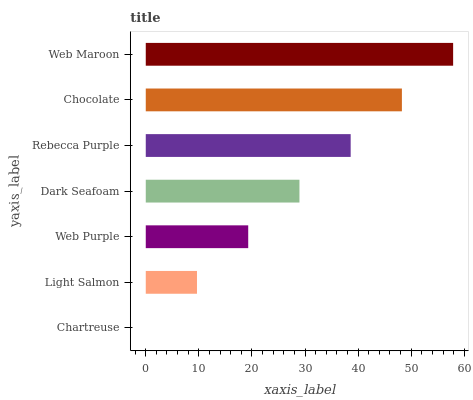Is Chartreuse the minimum?
Answer yes or no. Yes. Is Web Maroon the maximum?
Answer yes or no. Yes. Is Light Salmon the minimum?
Answer yes or no. No. Is Light Salmon the maximum?
Answer yes or no. No. Is Light Salmon greater than Chartreuse?
Answer yes or no. Yes. Is Chartreuse less than Light Salmon?
Answer yes or no. Yes. Is Chartreuse greater than Light Salmon?
Answer yes or no. No. Is Light Salmon less than Chartreuse?
Answer yes or no. No. Is Dark Seafoam the high median?
Answer yes or no. Yes. Is Dark Seafoam the low median?
Answer yes or no. Yes. Is Rebecca Purple the high median?
Answer yes or no. No. Is Light Salmon the low median?
Answer yes or no. No. 